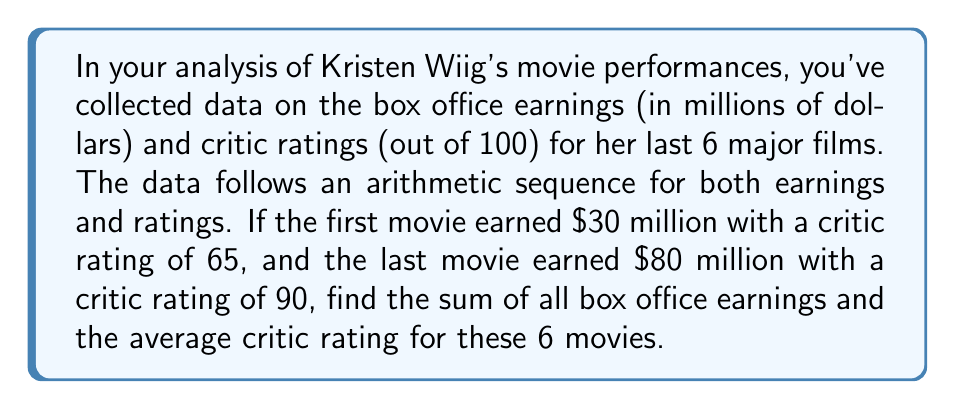Solve this math problem. Let's approach this problem step by step:

1) First, we need to find the common difference for both arithmetic sequences.

For box office earnings:
$a_1 = 30$, $a_6 = 80$
$d = \frac{a_6 - a_1}{6-1} = \frac{80 - 30}{5} = 10$

For critic ratings:
$a_1 = 65$, $a_6 = 90$
$d = \frac{a_6 - a_1}{6-1} = \frac{90 - 65}{5} = 5$

2) Now we can find the sum of box office earnings using the arithmetic series formula:

$$S_n = \frac{n}{2}(a_1 + a_n)$$

Where $n = 6$, $a_1 = 30$, and $a_6 = 80$

$$S_6 = \frac{6}{2}(30 + 80) = 3(110) = 330$$

3) For the average critic rating, we first need to find the sum of all ratings:

$$S_6 = \frac{6}{2}(65 + 90) = 3(155) = 465$$

Then we divide by the number of movies:

Average rating = $\frac{465}{6} = 77.5$
Answer: The sum of all box office earnings is $330 million, and the average critic rating is 77.5. 